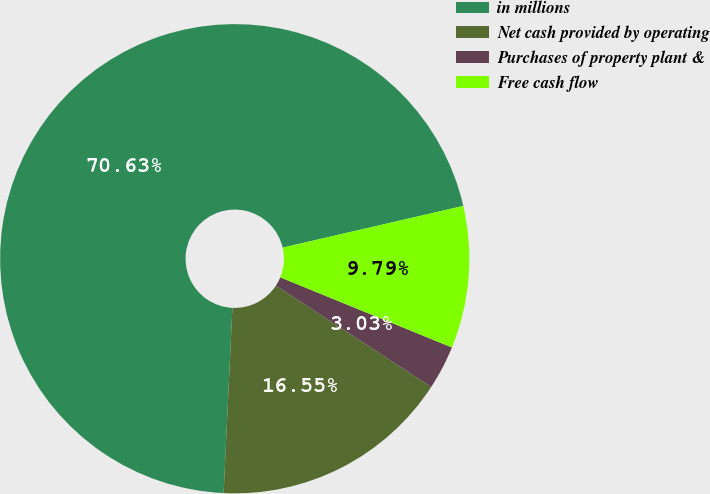Convert chart. <chart><loc_0><loc_0><loc_500><loc_500><pie_chart><fcel>in millions<fcel>Net cash provided by operating<fcel>Purchases of property plant &<fcel>Free cash flow<nl><fcel>70.63%<fcel>16.55%<fcel>3.03%<fcel>9.79%<nl></chart> 